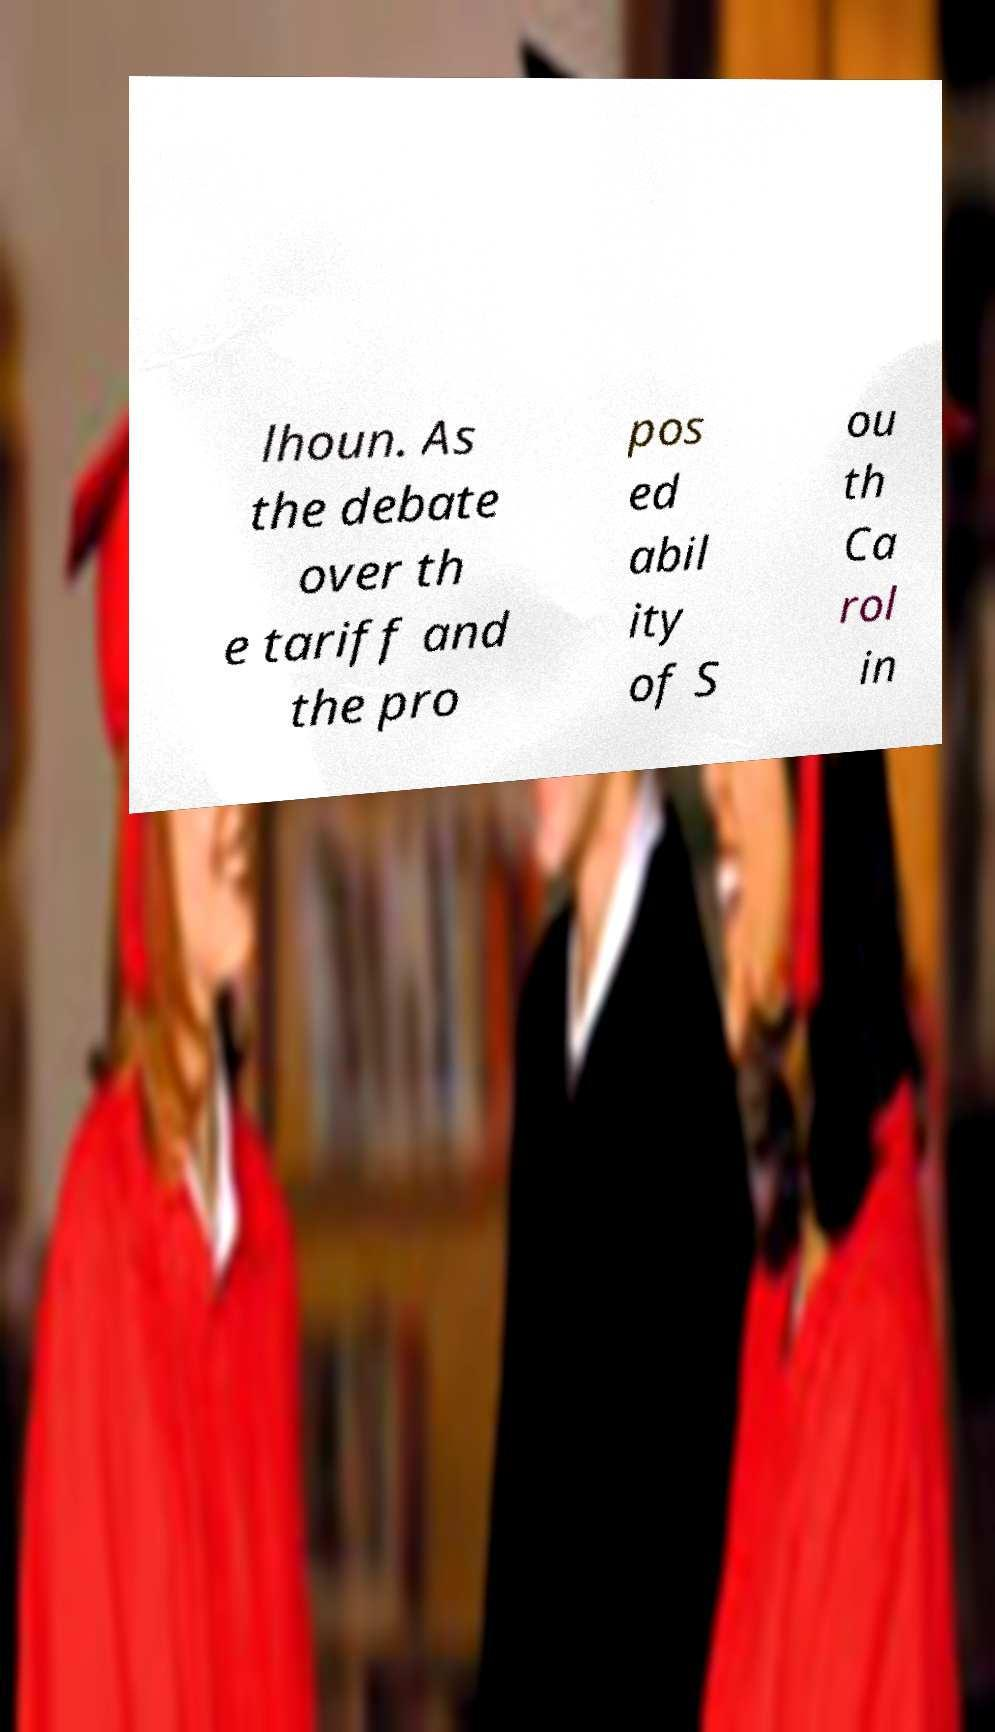For documentation purposes, I need the text within this image transcribed. Could you provide that? lhoun. As the debate over th e tariff and the pro pos ed abil ity of S ou th Ca rol in 